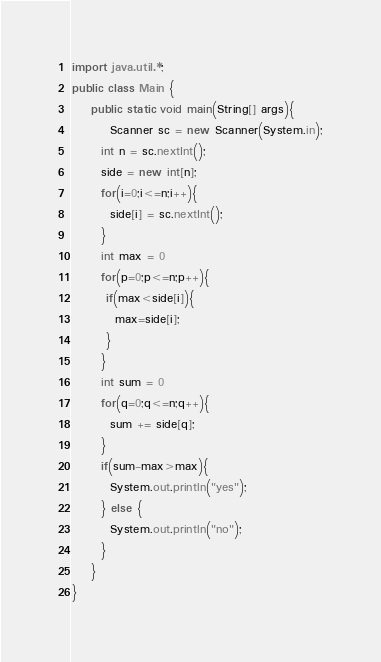Convert code to text. <code><loc_0><loc_0><loc_500><loc_500><_Java_>import java.util.*;
public class Main {
	public static void main(String[] args){
		Scanner sc = new Scanner(System.in);
      int n = sc.nextInt();
      side = new int[n];
      for(i=0;i<=n;i++){
        side[i] = sc.nextInt();
      }
      int max = 0
      for(p=0;p<=n;p++){
       if(max<side[i]){
         max=side[i];
       }
      }
      int sum = 0
      for(q=0;q<=n;q++){
        sum += side[q];
      }
      if(sum-max>max){
        System.out.println("yes");
      } else {
        System.out.println("no");
      }
	}
}

</code> 